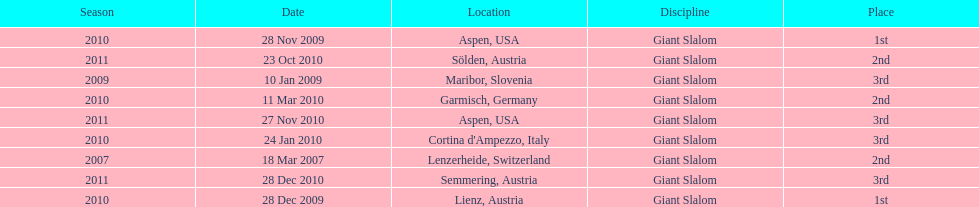What is the only location in the us? Aspen. 